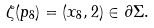Convert formula to latex. <formula><loc_0><loc_0><loc_500><loc_500>\zeta ( p _ { 8 } ) = ( x _ { 8 } , 2 ) \in \partial \Sigma .</formula> 